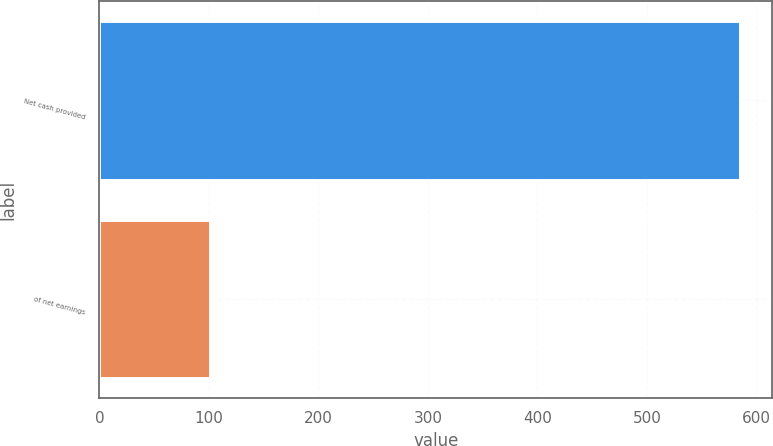<chart> <loc_0><loc_0><loc_500><loc_500><bar_chart><fcel>Net cash provided<fcel>of net earnings<nl><fcel>585.2<fcel>101.1<nl></chart> 